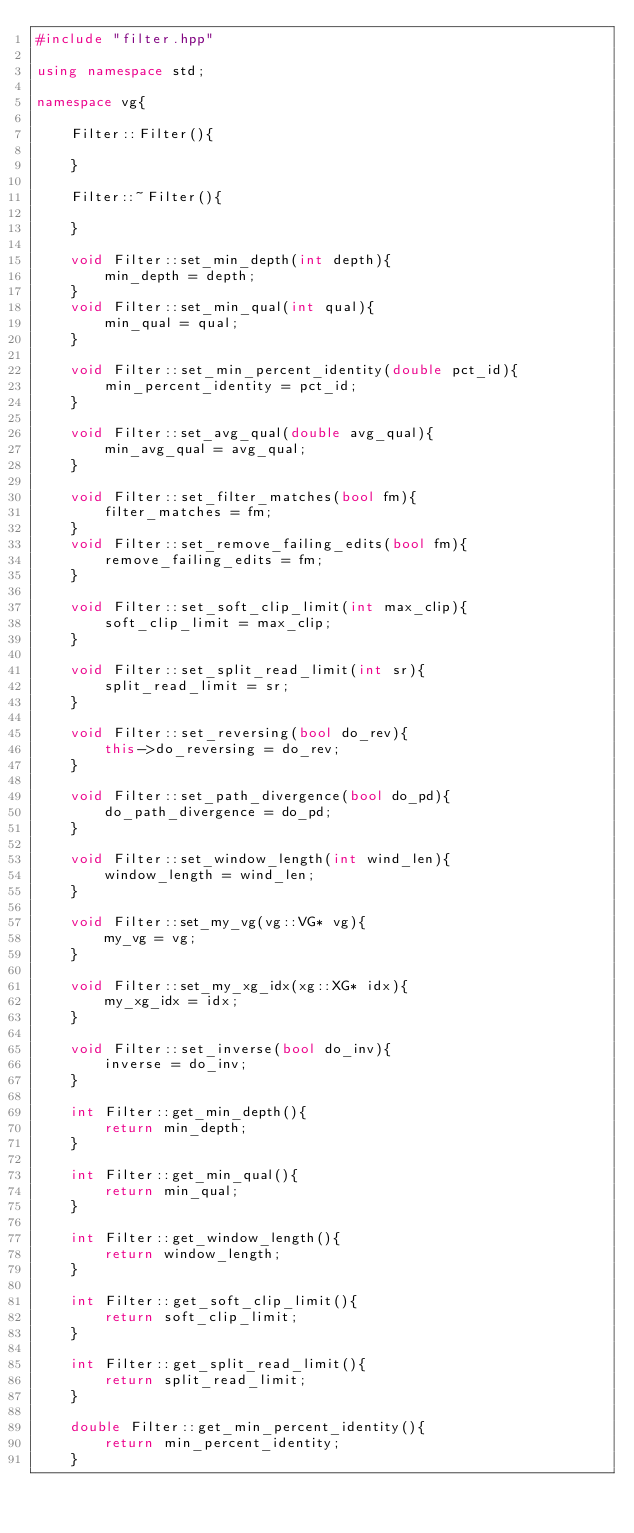<code> <loc_0><loc_0><loc_500><loc_500><_C++_>#include "filter.hpp"

using namespace std;

namespace vg{

    Filter::Filter(){

    }

    Filter::~Filter(){

    }

    void Filter::set_min_depth(int depth){
        min_depth = depth;
    }
    void Filter::set_min_qual(int qual){
        min_qual = qual;
    }

    void Filter::set_min_percent_identity(double pct_id){
        min_percent_identity = pct_id;
    }

    void Filter::set_avg_qual(double avg_qual){
        min_avg_qual = avg_qual;
    }

    void Filter::set_filter_matches(bool fm){
        filter_matches = fm;
    }
    void Filter::set_remove_failing_edits(bool fm){
        remove_failing_edits = fm;
    }

    void Filter::set_soft_clip_limit(int max_clip){
        soft_clip_limit = max_clip;
    }

    void Filter::set_split_read_limit(int sr){
        split_read_limit = sr;
    }

    void Filter::set_reversing(bool do_rev){
        this->do_reversing = do_rev;
    }

    void Filter::set_path_divergence(bool do_pd){
        do_path_divergence = do_pd;
    }

    void Filter::set_window_length(int wind_len){
        window_length = wind_len;
    }

    void Filter::set_my_vg(vg::VG* vg){
        my_vg = vg;
    }

    void Filter::set_my_xg_idx(xg::XG* idx){
        my_xg_idx = idx;
    }

    void Filter::set_inverse(bool do_inv){
        inverse = do_inv;
    }

    int Filter::get_min_depth(){
        return min_depth;
    }

    int Filter::get_min_qual(){
        return min_qual;
    }

    int Filter::get_window_length(){
        return window_length;
    }

    int Filter::get_soft_clip_limit(){
        return soft_clip_limit;
    }

    int Filter::get_split_read_limit(){
        return split_read_limit;
    }

    double Filter::get_min_percent_identity(){
        return min_percent_identity;
    }
</code> 